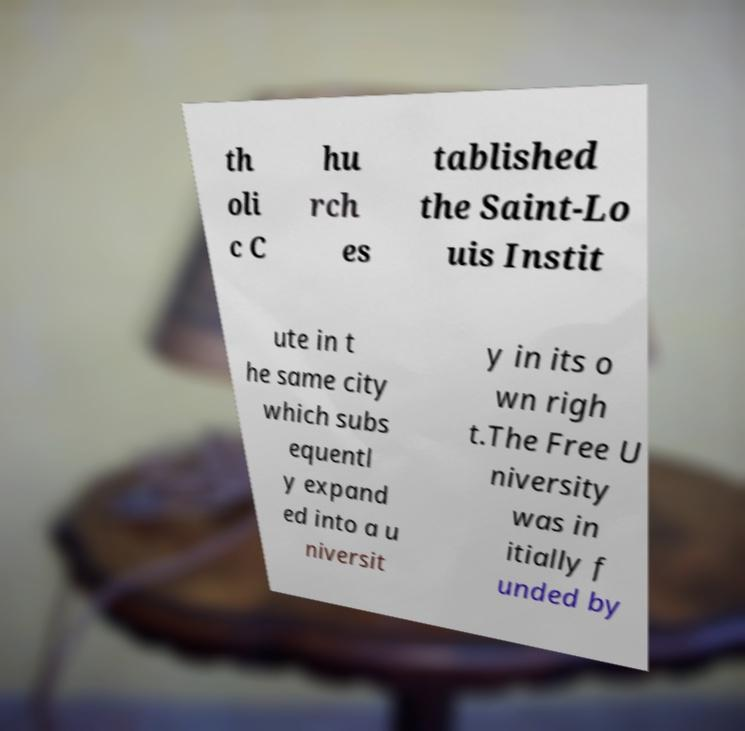What messages or text are displayed in this image? I need them in a readable, typed format. th oli c C hu rch es tablished the Saint-Lo uis Instit ute in t he same city which subs equentl y expand ed into a u niversit y in its o wn righ t.The Free U niversity was in itially f unded by 